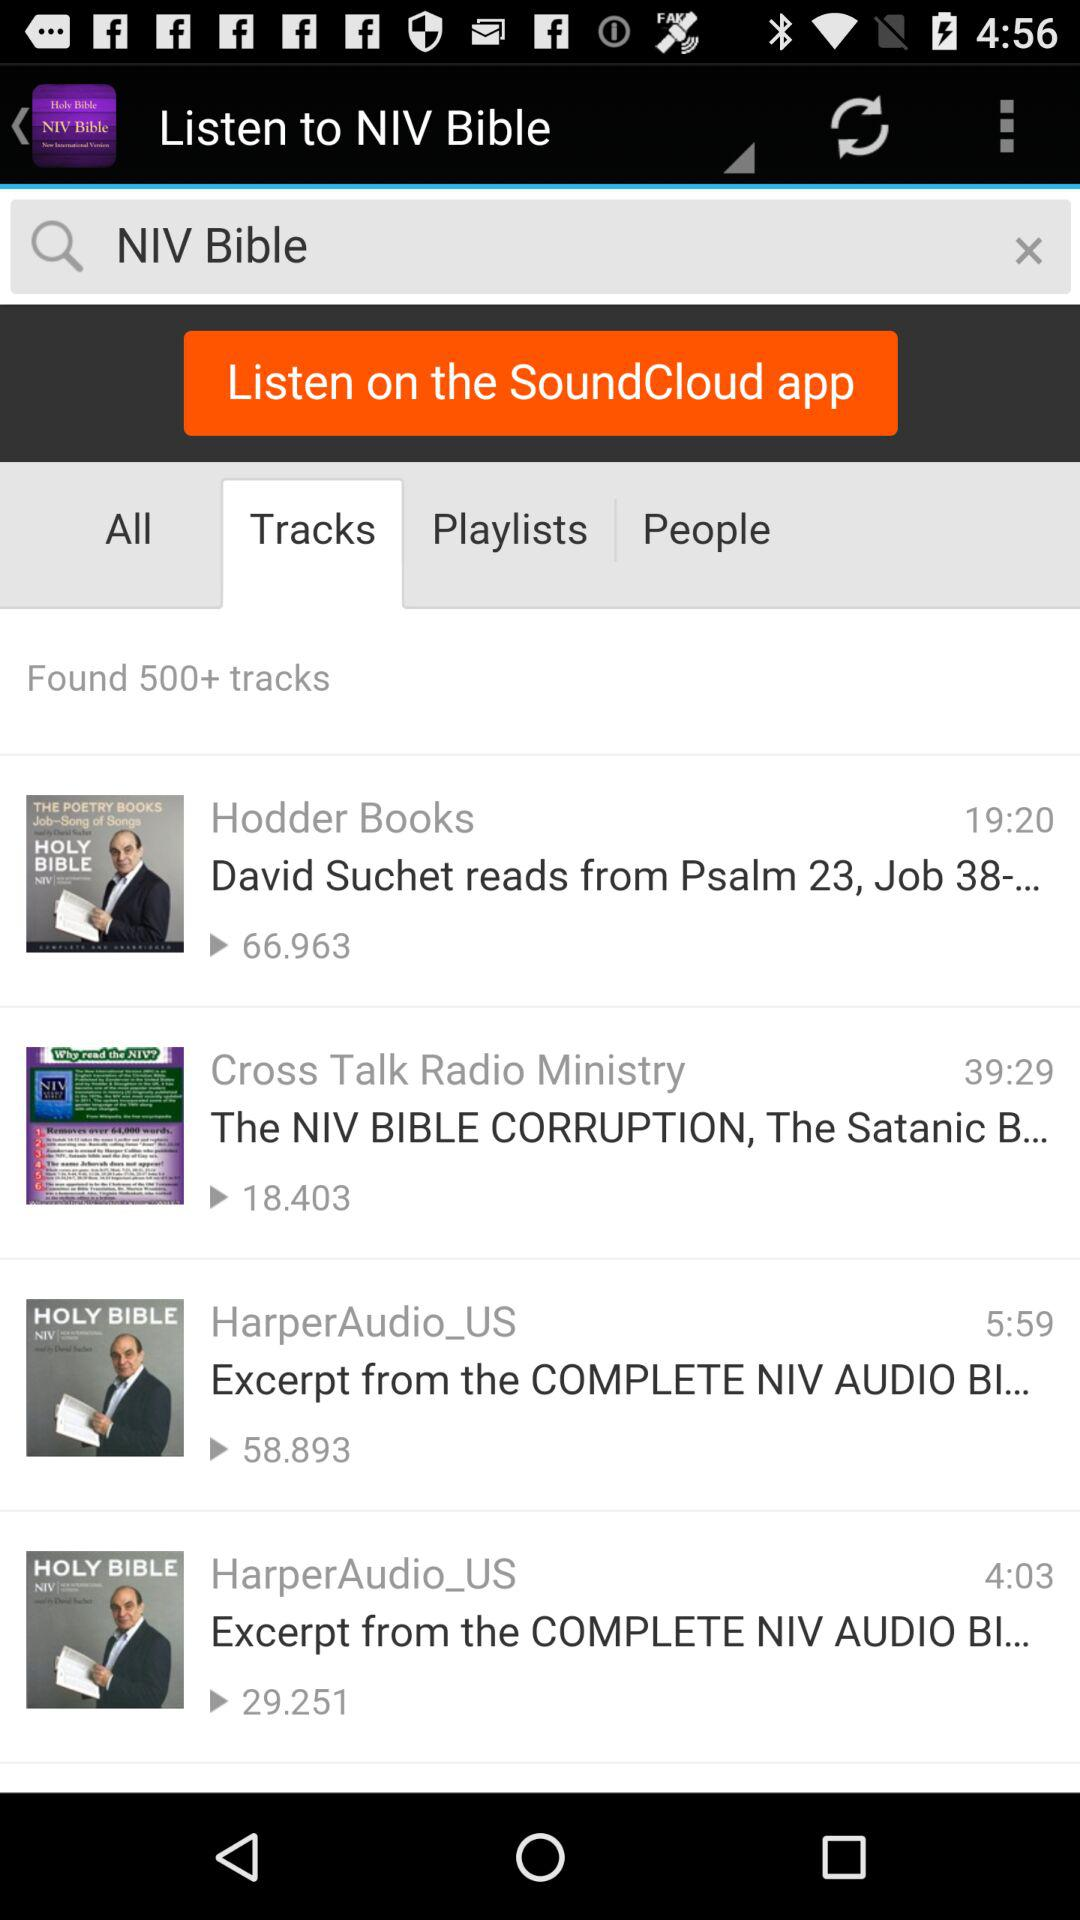What is the Total views on hodder books?
When the provided information is insufficient, respond with <no answer>. <no answer> 